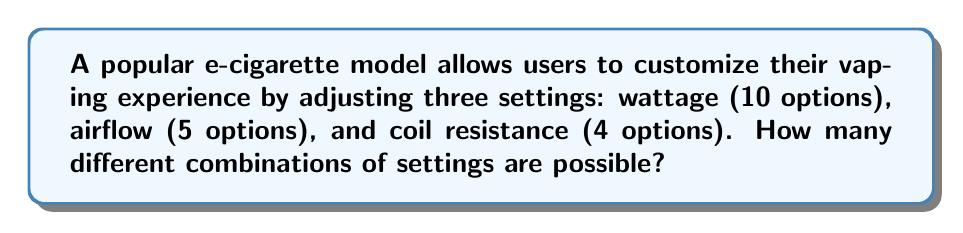Teach me how to tackle this problem. To solve this problem, we'll use the multiplication principle of counting. This principle states that if we have a series of independent choices, the total number of possible outcomes is the product of the number of options for each choice.

Let's break it down step-by-step:

1. Wattage options: 10 choices
2. Airflow options: 5 choices
3. Coil resistance options: 4 choices

Each of these settings can be chosen independently of the others. Therefore, we multiply the number of options for each setting:

$$ \text{Total combinations} = 10 \times 5 \times 4 $$

$$ \text{Total combinations} = 200 $$

This means that there are 200 different possible combinations of settings that a user can choose from when customizing their vaping experience with this e-cigarette model.
Answer: 200 